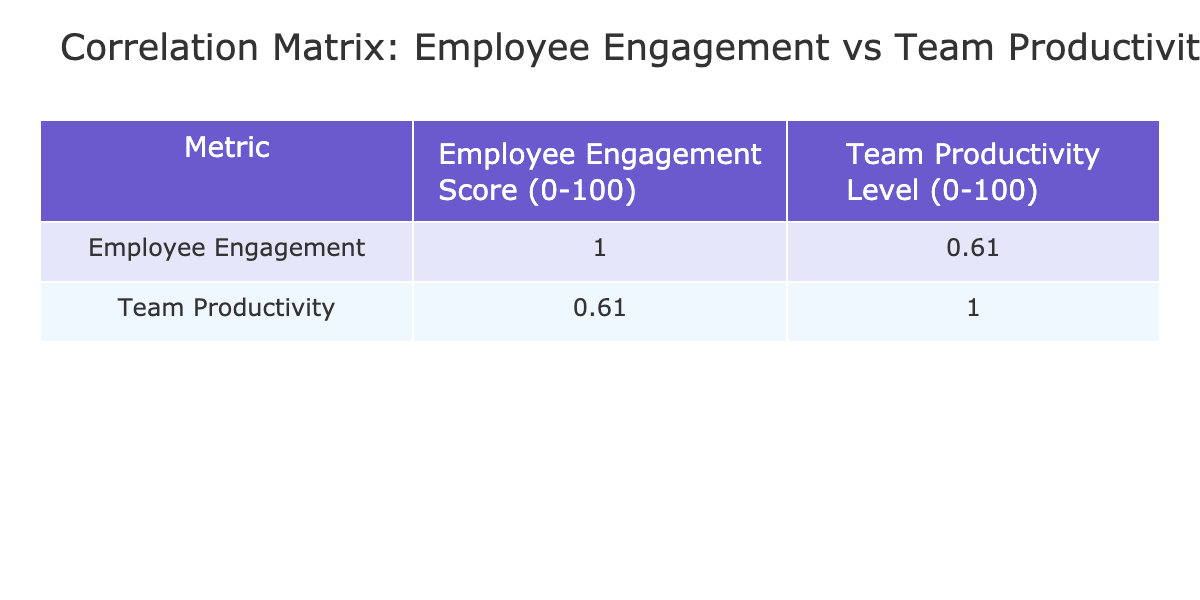What is the Employee Engagement Score for the Finance team? The table shows a column for Employee Engagement Scores, and the row for Finance indicates a score of 88.
Answer: 88 Which team has the highest Team Productivity Level? By scanning the Team Productivity Level column, the highest value is 92, which corresponds to the Product team.
Answer: Product Is the correlation between Employee Engagement Score and Team Productivity Level positive? The correlation coefficient indicates a positive relationship, as higher engagement scores generally relate to higher productivity levels in the table.
Answer: Yes What is the average Employee Engagement Score for all teams? To calculate the average, we sum the Employee Engagement Scores (85 + 78 + 90 + 82 + 76 + 88 + 80 + 84 + 75 + 89 = 84.3) and divide by the number of teams (10). So, 84.3 / 10 = 84.3.
Answer: 84.3 Which team shows a Team Productivity Level lower than their Employee Engagement Score? Reviewing the table, the HR team has an Employee Engagement Score of 76 and a Team Productivity Level of 70, which is lower.
Answer: HR What is the difference between the highest and lowest Team Productivity levels? The highest Team Productivity Level is 92 (Product team), and the lowest is 70 (HR team). The difference is 92 - 70 = 22.
Answer: 22 Do all teams have Employee Engagement Scores above 75? Checking each score in the Employee Engagement Score column, we find that all teams except for HR (76) are above this threshold.
Answer: No What is the median Team Productivity Level from the provided data? First, we list the Team Productivity levels in order (70, 75, 78, 80, 80, 85, 87, 88, 90, 92). The median, which is the average of the 5th and 6th values (80 and 85), is (80 + 85) / 2 = 82.5.
Answer: 82.5 Which teams have both Employee Engagement Scores and Team Productivity Levels above 80? We look at the table and find that Finance, Product, Sales, and Research teams have both metrics above 80.
Answer: Finance, Product, Sales, Research 